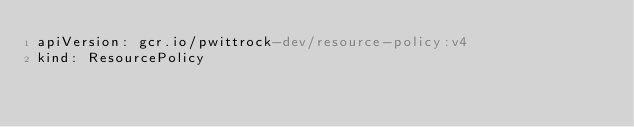<code> <loc_0><loc_0><loc_500><loc_500><_YAML_>apiVersion: gcr.io/pwittrock-dev/resource-policy:v4
kind: ResourcePolicy
</code> 